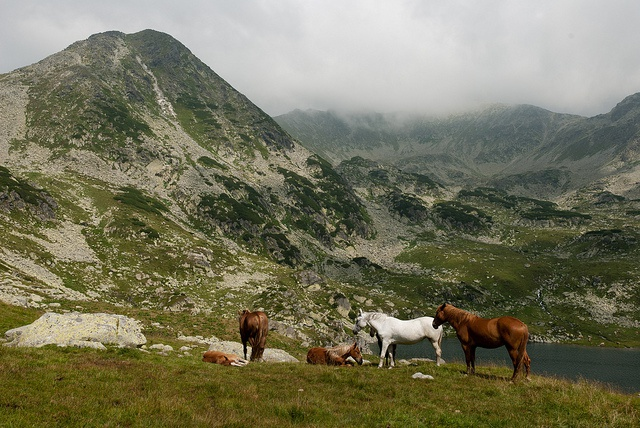Describe the objects in this image and their specific colors. I can see horse in lightgray, black, maroon, olive, and brown tones, horse in lightgray, darkgray, and black tones, horse in lightgray, black, maroon, and brown tones, horse in lightgray, maroon, black, and gray tones, and horse in lightgray, maroon, brown, and gray tones in this image. 